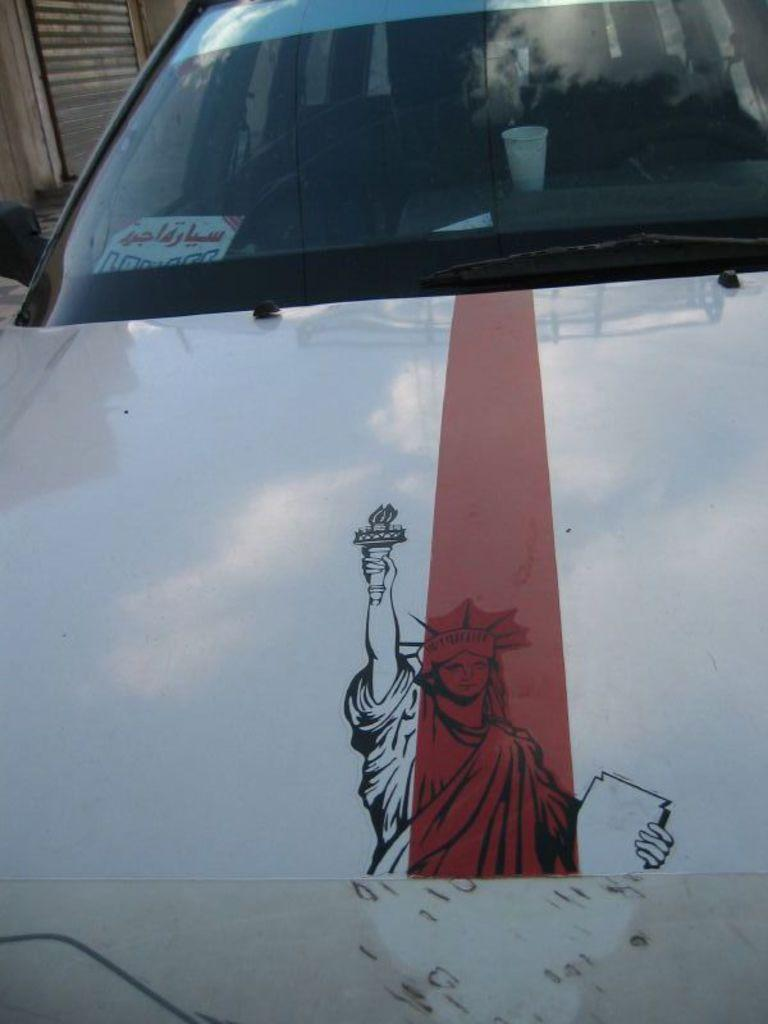What is the main subject of the image? There is a car in the image. What can be found inside the car? There is a paper and a glass inside the car. Can you describe any additional features of the image? There is a shutter at the top left of the image. What type of friction can be observed between the duck and the hair in the image? There is no duck or hair present in the image, so no friction can be observed between them. 